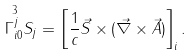Convert formula to latex. <formula><loc_0><loc_0><loc_500><loc_500>\overset { 3 } { \Gamma _ { i 0 } ^ { j } } S _ { j } = \left [ \frac { 1 } { c } \vec { S } \times ( \vec { \nabla } \times \vec { A } ) \right ] _ { i } .</formula> 